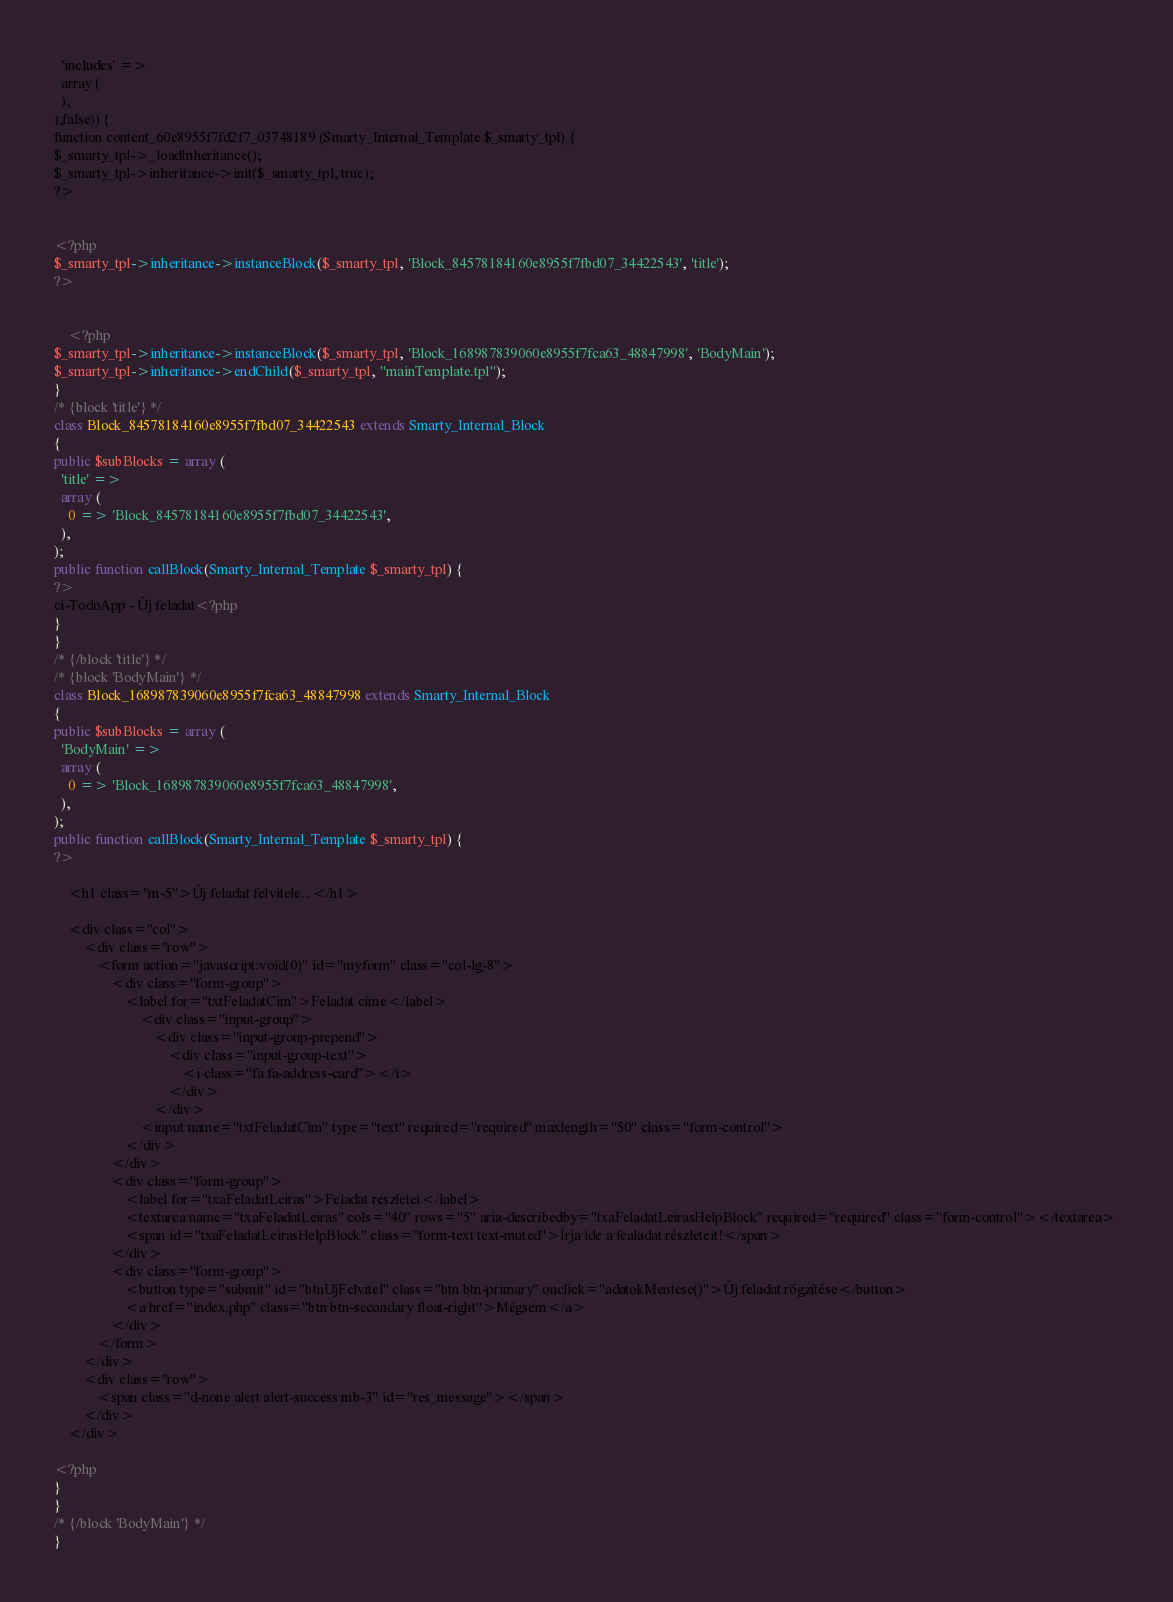<code> <loc_0><loc_0><loc_500><loc_500><_PHP_>  'includes' => 
  array (
  ),
),false)) {
function content_60e8955f7fd2f7_03748189 (Smarty_Internal_Template $_smarty_tpl) {
$_smarty_tpl->_loadInheritance();
$_smarty_tpl->inheritance->init($_smarty_tpl, true);
?>


<?php 
$_smarty_tpl->inheritance->instanceBlock($_smarty_tpl, 'Block_84578184160e8955f7fbd07_34422543', 'title');
?>


    <?php 
$_smarty_tpl->inheritance->instanceBlock($_smarty_tpl, 'Block_168987839060e8955f7fca63_48847998', 'BodyMain');
$_smarty_tpl->inheritance->endChild($_smarty_tpl, "mainTemplate.tpl");
}
/* {block 'title'} */
class Block_84578184160e8955f7fbd07_34422543 extends Smarty_Internal_Block
{
public $subBlocks = array (
  'title' => 
  array (
    0 => 'Block_84578184160e8955f7fbd07_34422543',
  ),
);
public function callBlock(Smarty_Internal_Template $_smarty_tpl) {
?>
ci-TodoApp - Új feladat<?php
}
}
/* {/block 'title'} */
/* {block 'BodyMain'} */
class Block_168987839060e8955f7fca63_48847998 extends Smarty_Internal_Block
{
public $subBlocks = array (
  'BodyMain' => 
  array (
    0 => 'Block_168987839060e8955f7fca63_48847998',
  ),
);
public function callBlock(Smarty_Internal_Template $_smarty_tpl) {
?>

    <h1 class="m-5">Új feladat felvitele...</h1>

    <div class="col">
        <div class="row">
            <form action="javascript:void(0)" id="myform" class="col-lg-8">
                <div class="form-group">
                    <label for="txtFeladatCim">Feladat címe</label> 
                        <div class="input-group">
                            <div class="input-group-prepend">
                                <div class="input-group-text">
                                    <i class="fa fa-address-card"></i>
                                </div>
                            </div> 
                        <input name="txtFeladatCim" type="text" required="required" maxlength="50" class="form-control">
                    </div>
                </div>
                <div class="form-group">
                    <label for="txaFeladatLeiras">Feladat részletei</label> 
                    <textarea name="txaFeladatLeiras" cols="40" rows="5" aria-describedby="txaFeladatLeirasHelpBlock" required="required" class="form-control"></textarea> 
                    <span id="txaFeladatLeirasHelpBlock" class="form-text text-muted">Írja ide a fealadat részleteit!</span>
                </div> 
                <div class="form-group">
                    <button type="submit" id="btnUjFelvitel" class="btn btn-primary" onclick="adatokMentese()">Új feladat rögzítése</button>
                    <a href="index.php" class="btn btn-secondary float-right">Mégsem</a>
                </div>
            </form>
        </div>
        <div class="row">
            <span class="d-none alert alert-success mb-3" id="res_message"></span>
        </div>
    </div>

<?php
}
}
/* {/block 'BodyMain'} */
}
</code> 